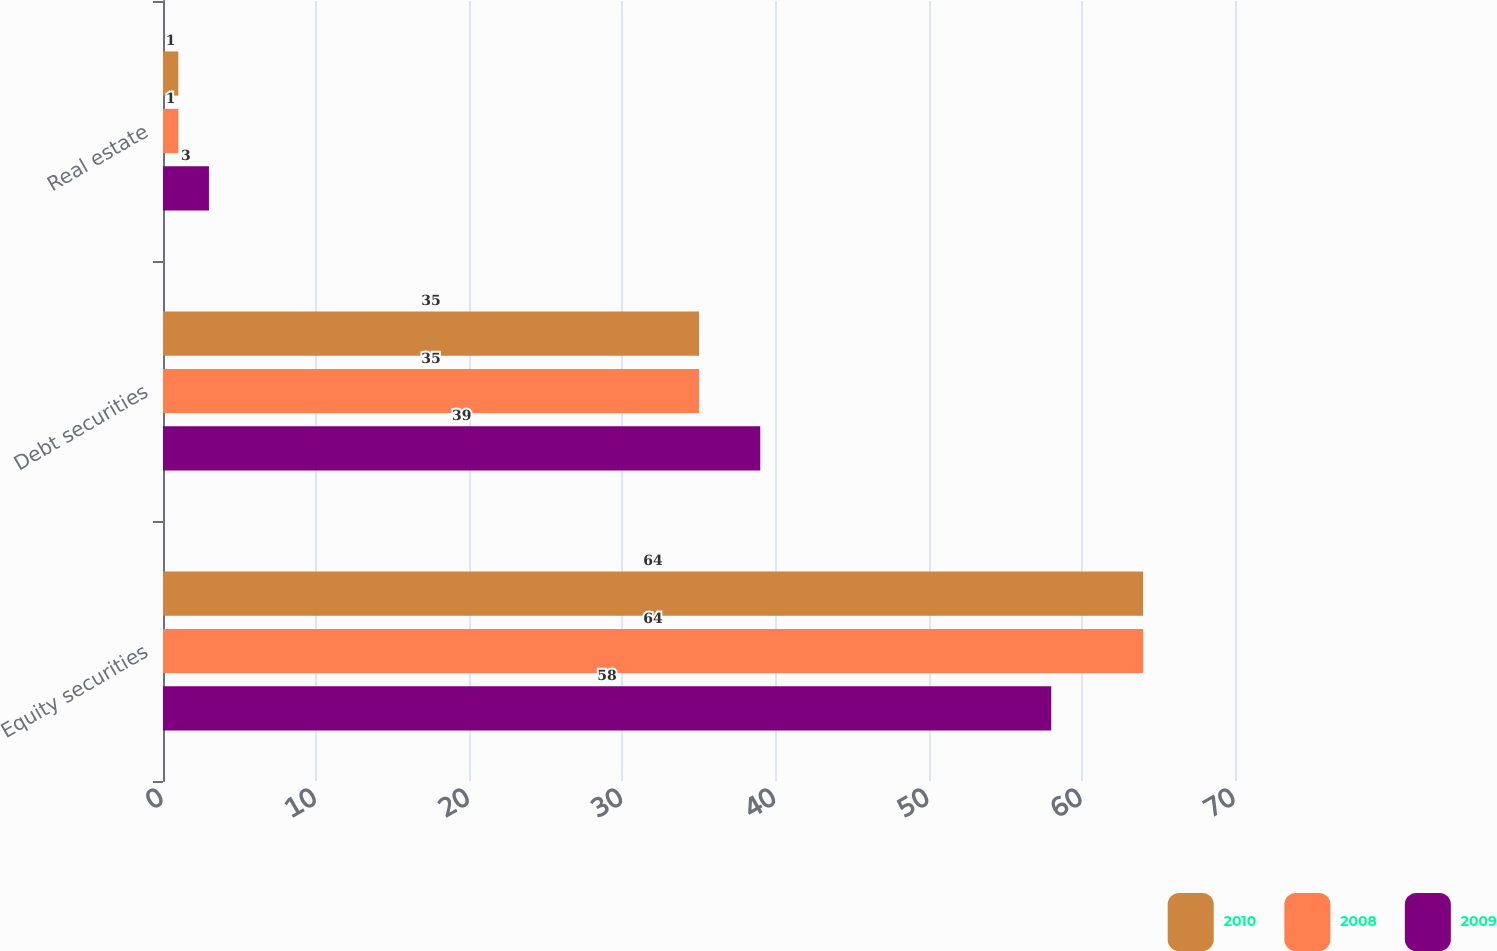<chart> <loc_0><loc_0><loc_500><loc_500><stacked_bar_chart><ecel><fcel>Equity securities<fcel>Debt securities<fcel>Real estate<nl><fcel>2010<fcel>64<fcel>35<fcel>1<nl><fcel>2008<fcel>64<fcel>35<fcel>1<nl><fcel>2009<fcel>58<fcel>39<fcel>3<nl></chart> 